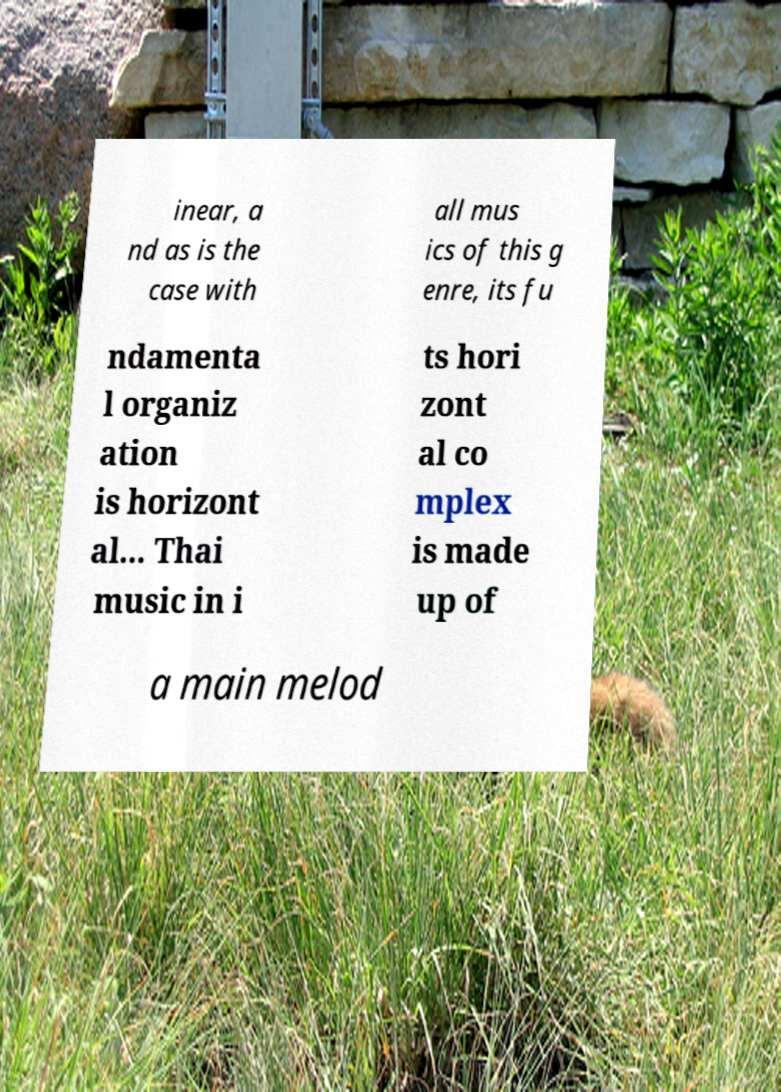Could you assist in decoding the text presented in this image and type it out clearly? inear, a nd as is the case with all mus ics of this g enre, its fu ndamenta l organiz ation is horizont al... Thai music in i ts hori zont al co mplex is made up of a main melod 